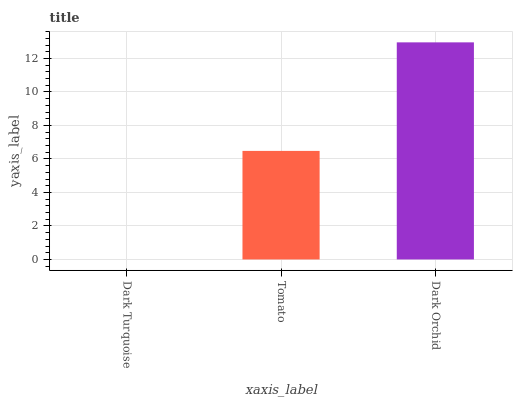Is Dark Turquoise the minimum?
Answer yes or no. Yes. Is Dark Orchid the maximum?
Answer yes or no. Yes. Is Tomato the minimum?
Answer yes or no. No. Is Tomato the maximum?
Answer yes or no. No. Is Tomato greater than Dark Turquoise?
Answer yes or no. Yes. Is Dark Turquoise less than Tomato?
Answer yes or no. Yes. Is Dark Turquoise greater than Tomato?
Answer yes or no. No. Is Tomato less than Dark Turquoise?
Answer yes or no. No. Is Tomato the high median?
Answer yes or no. Yes. Is Tomato the low median?
Answer yes or no. Yes. Is Dark Turquoise the high median?
Answer yes or no. No. Is Dark Turquoise the low median?
Answer yes or no. No. 